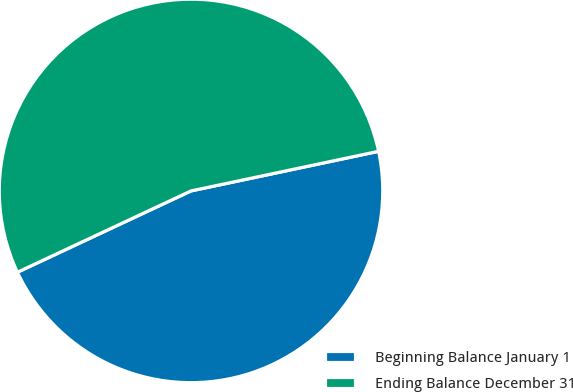Convert chart. <chart><loc_0><loc_0><loc_500><loc_500><pie_chart><fcel>Beginning Balance January 1<fcel>Ending Balance December 31<nl><fcel>46.34%<fcel>53.66%<nl></chart> 